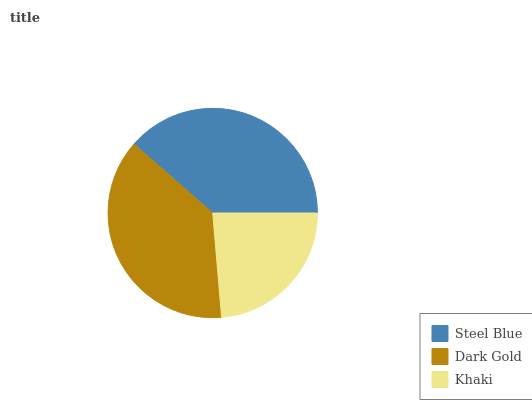Is Khaki the minimum?
Answer yes or no. Yes. Is Steel Blue the maximum?
Answer yes or no. Yes. Is Dark Gold the minimum?
Answer yes or no. No. Is Dark Gold the maximum?
Answer yes or no. No. Is Steel Blue greater than Dark Gold?
Answer yes or no. Yes. Is Dark Gold less than Steel Blue?
Answer yes or no. Yes. Is Dark Gold greater than Steel Blue?
Answer yes or no. No. Is Steel Blue less than Dark Gold?
Answer yes or no. No. Is Dark Gold the high median?
Answer yes or no. Yes. Is Dark Gold the low median?
Answer yes or no. Yes. Is Steel Blue the high median?
Answer yes or no. No. Is Steel Blue the low median?
Answer yes or no. No. 